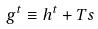<formula> <loc_0><loc_0><loc_500><loc_500>g ^ { t } \equiv h ^ { t } + T s</formula> 